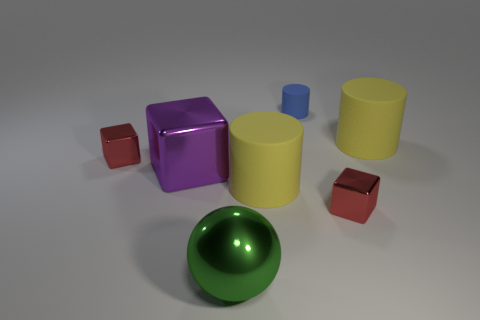Subtract all yellow spheres. How many yellow cylinders are left? 2 Add 2 green balls. How many objects exist? 9 Subtract all yellow cylinders. How many cylinders are left? 1 Subtract 1 cylinders. How many cylinders are left? 2 Subtract all spheres. How many objects are left? 6 Subtract all large shiny spheres. Subtract all small metal things. How many objects are left? 4 Add 4 big green metal spheres. How many big green metal spheres are left? 5 Add 2 small rubber things. How many small rubber things exist? 3 Subtract 0 red cylinders. How many objects are left? 7 